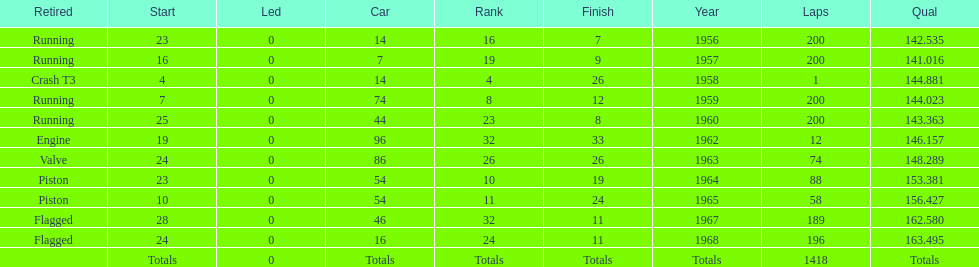How many times was bob veith ranked higher than 10 at an indy 500? 2. 